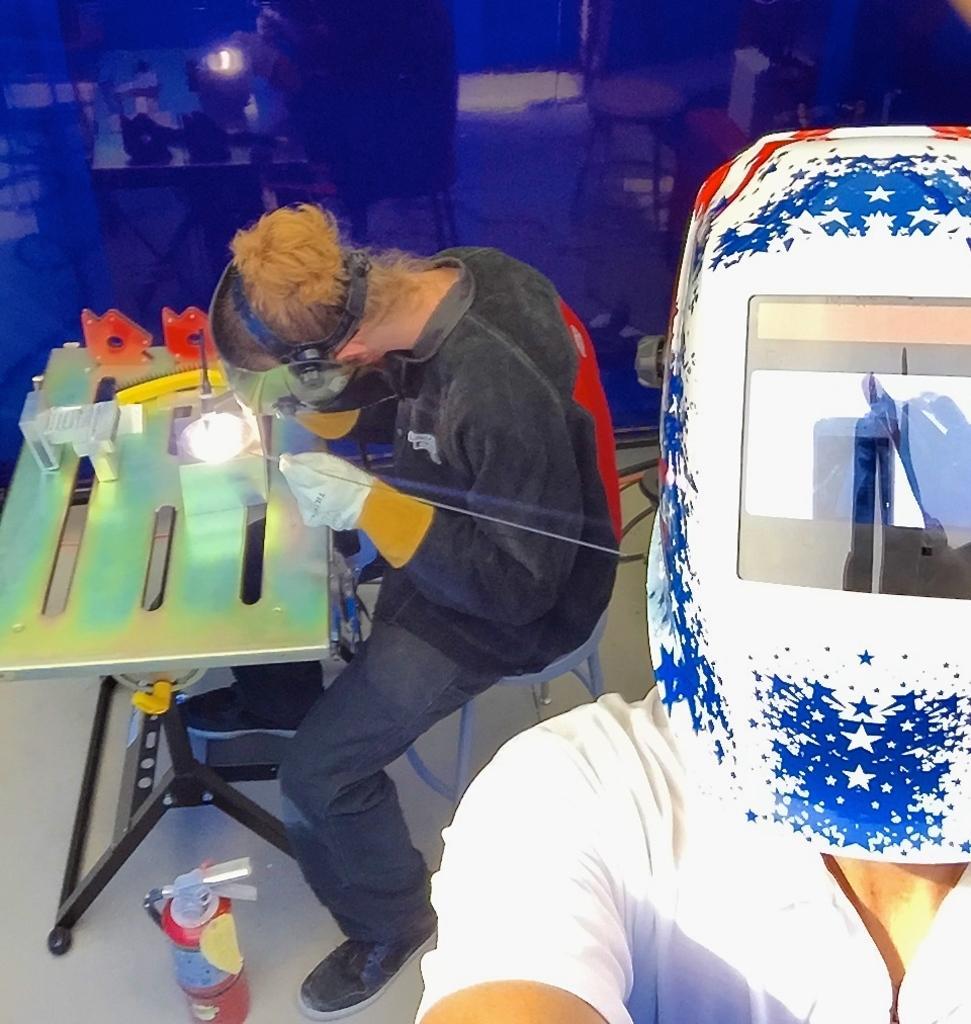Could you give a brief overview of what you see in this image? On the right side, there is a person in white color shirt, wearing a mask. On the left side, there is a person sitting and working. Beside him, there is a table, on which there are some objects and there is a tin on the floor. 